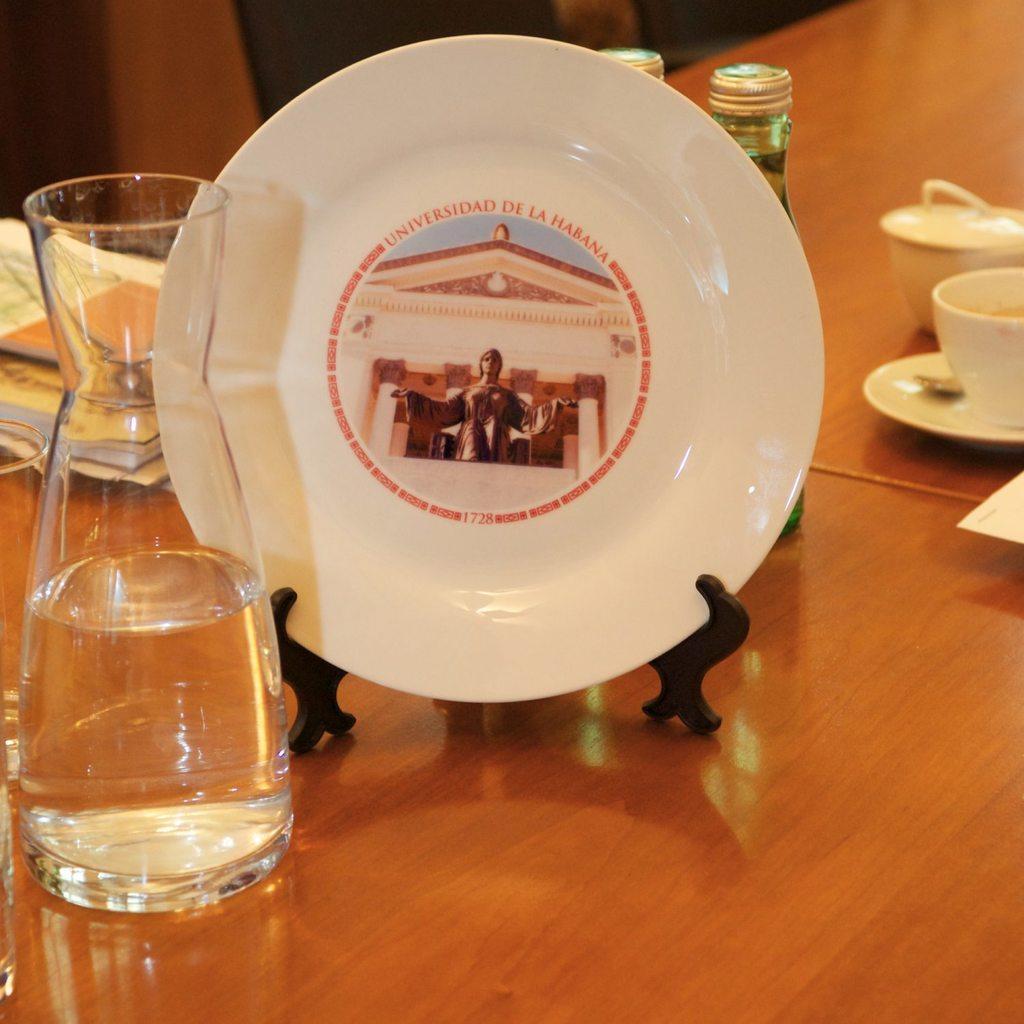How would you summarize this image in a sentence or two? In this image we can see a table on which there is a plate with some text on it. There is a flask with water. There are cups and other objects. There are books. 